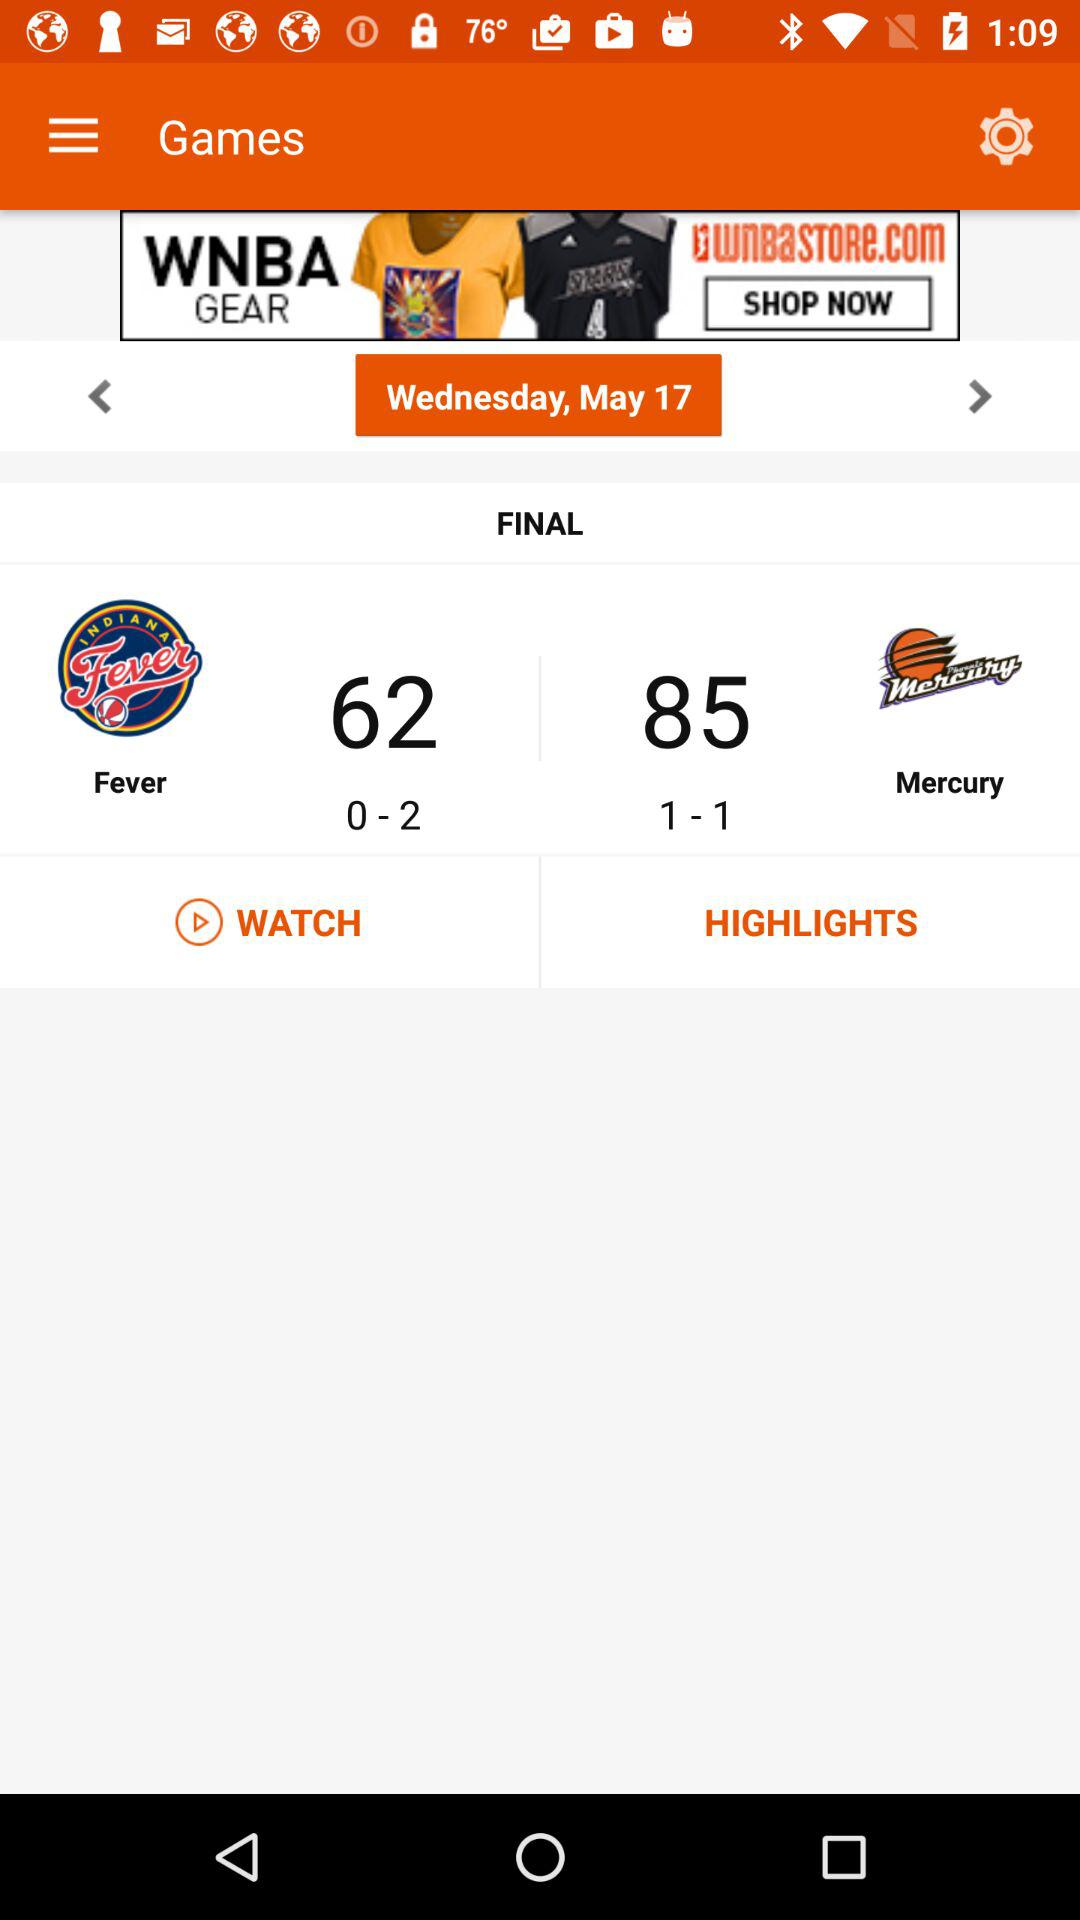What is the total score of the "Mercury"? The total score is 85. 